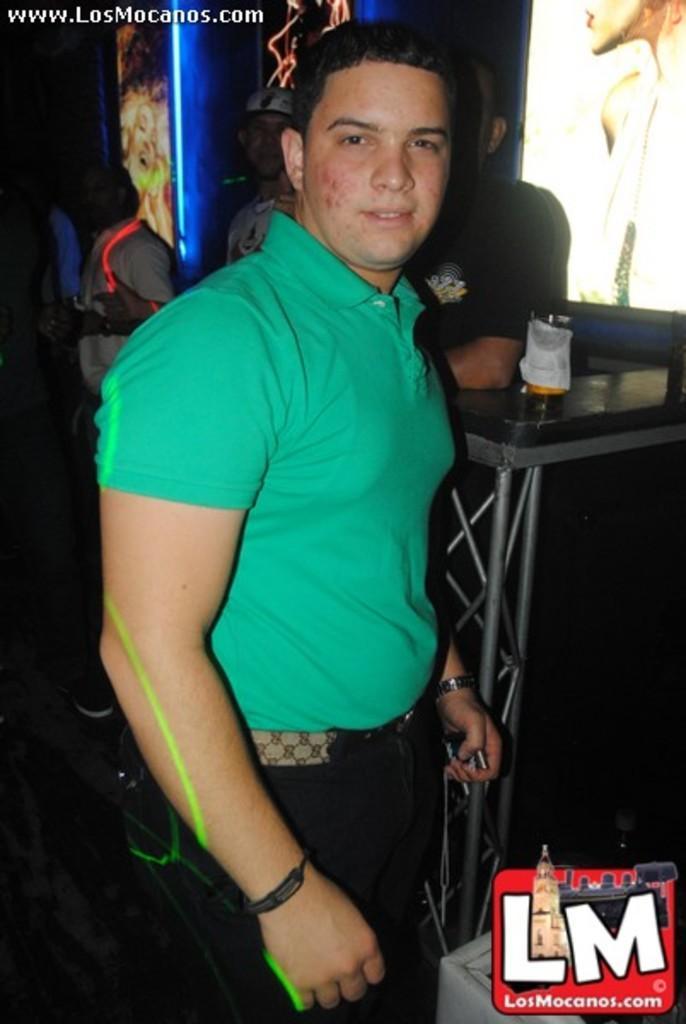Please provide a concise description of this image. In this image we can see a man is standing. Behind the man, we can see people, glass and a table. There is a watermark in the right bottom of the image. In the background, we can see screens. 